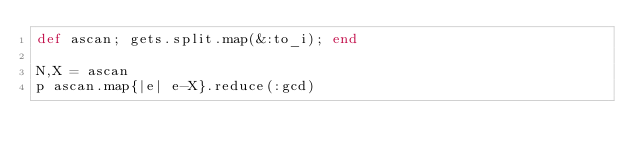<code> <loc_0><loc_0><loc_500><loc_500><_Ruby_>def ascan; gets.split.map(&:to_i); end

N,X = ascan
p ascan.map{|e| e-X}.reduce(:gcd)</code> 